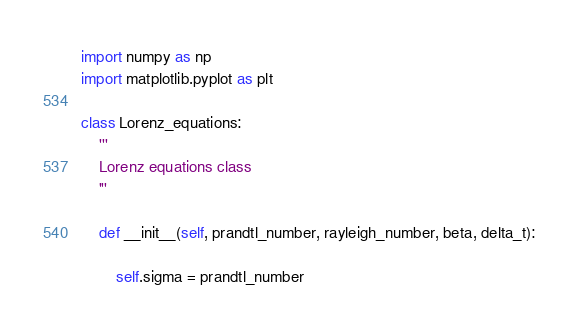<code> <loc_0><loc_0><loc_500><loc_500><_Python_>import numpy as np
import matplotlib.pyplot as plt

class Lorenz_equations:
    '''
    Lorenz equations class
    '''

    def __init__(self, prandtl_number, rayleigh_number, beta, delta_t):
        
        self.sigma = prandtl_number</code> 